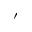<formula> <loc_0><loc_0><loc_500><loc_500>^ { \prime }</formula> 